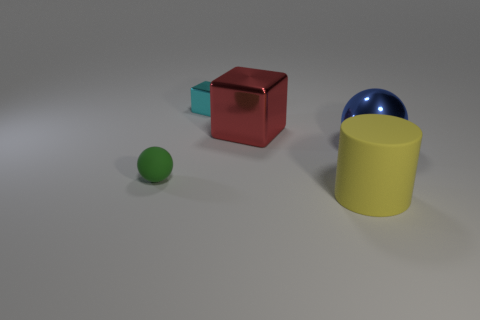Add 3 purple cylinders. How many objects exist? 8 Subtract all blocks. How many objects are left? 3 Add 2 large yellow matte cylinders. How many large yellow matte cylinders exist? 3 Subtract 1 yellow cylinders. How many objects are left? 4 Subtract all metal spheres. Subtract all large yellow cylinders. How many objects are left? 3 Add 3 red objects. How many red objects are left? 4 